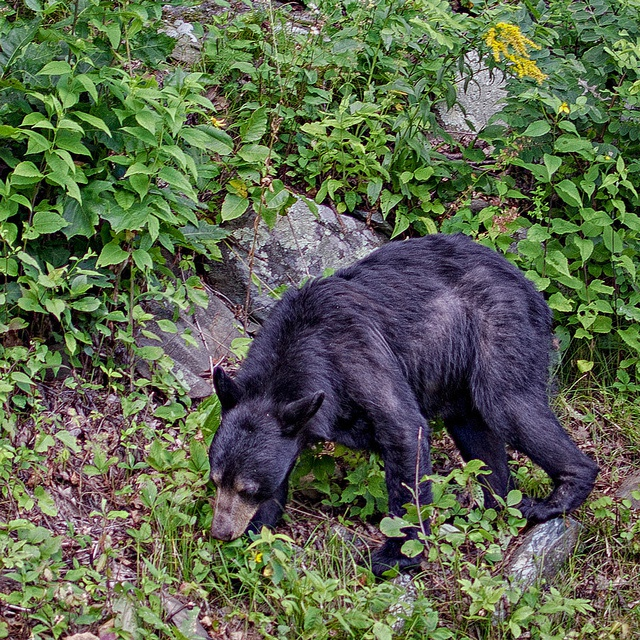Describe the objects in this image and their specific colors. I can see a bear in green, black, purple, and navy tones in this image. 